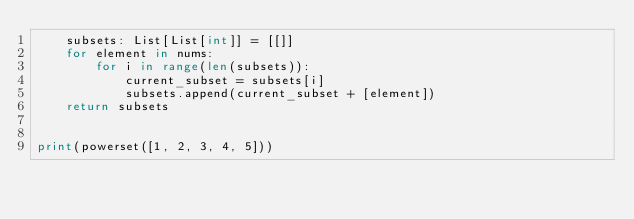Convert code to text. <code><loc_0><loc_0><loc_500><loc_500><_Python_>    subsets: List[List[int]] = [[]]
    for element in nums:
        for i in range(len(subsets)):
            current_subset = subsets[i]
            subsets.append(current_subset + [element])
    return subsets


print(powerset([1, 2, 3, 4, 5]))
</code> 